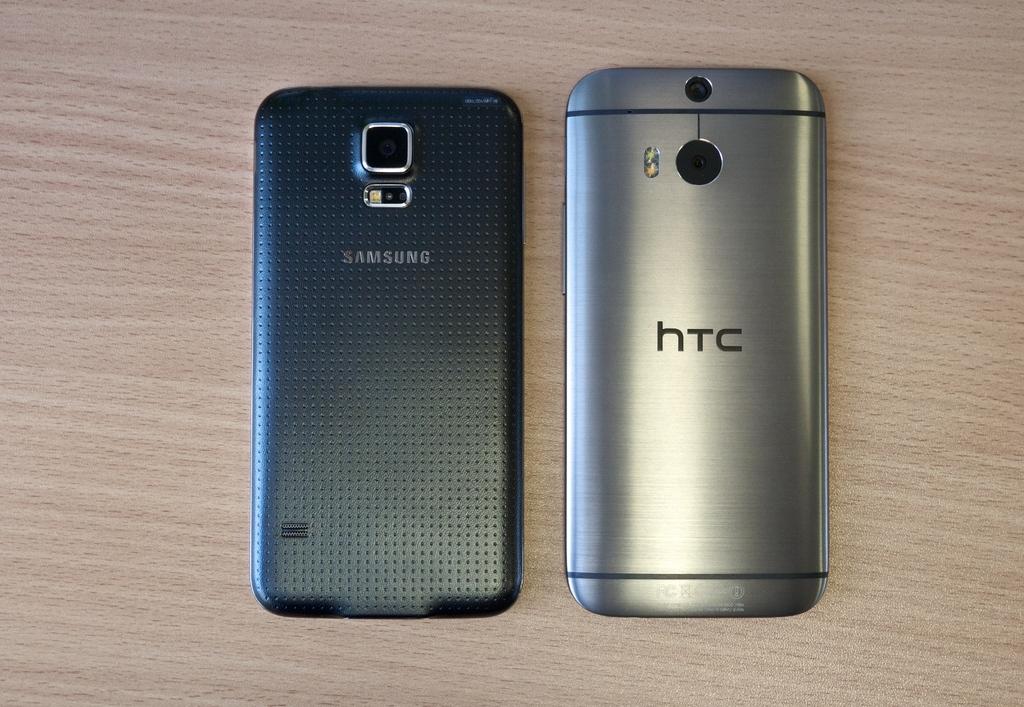What brand phone is on the right?
Your answer should be very brief. Htc. What brand of phone is on the left?
Your response must be concise. Samsung. 